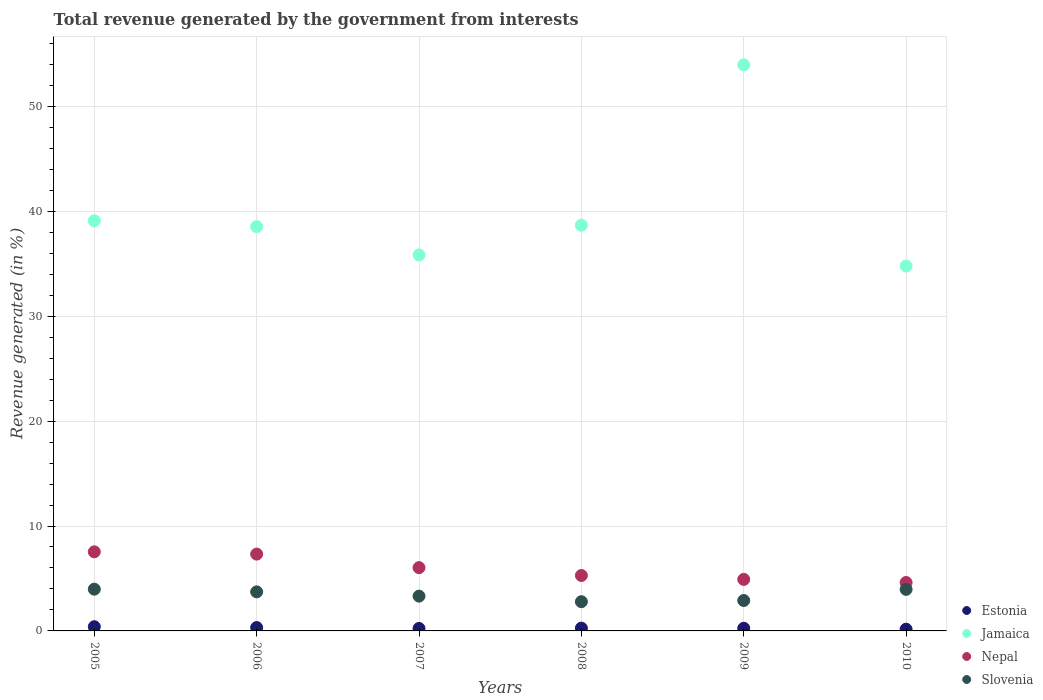What is the total revenue generated in Slovenia in 2008?
Give a very brief answer. 2.79. Across all years, what is the maximum total revenue generated in Jamaica?
Make the answer very short. 53.97. Across all years, what is the minimum total revenue generated in Slovenia?
Give a very brief answer. 2.79. What is the total total revenue generated in Slovenia in the graph?
Offer a terse response. 20.66. What is the difference between the total revenue generated in Jamaica in 2006 and that in 2008?
Make the answer very short. -0.14. What is the difference between the total revenue generated in Jamaica in 2009 and the total revenue generated in Slovenia in 2010?
Your answer should be compact. 50. What is the average total revenue generated in Estonia per year?
Make the answer very short. 0.27. In the year 2007, what is the difference between the total revenue generated in Nepal and total revenue generated in Slovenia?
Your answer should be very brief. 2.72. What is the ratio of the total revenue generated in Jamaica in 2005 to that in 2010?
Ensure brevity in your answer.  1.12. Is the total revenue generated in Jamaica in 2005 less than that in 2009?
Give a very brief answer. Yes. What is the difference between the highest and the second highest total revenue generated in Slovenia?
Ensure brevity in your answer.  0.02. What is the difference between the highest and the lowest total revenue generated in Jamaica?
Keep it short and to the point. 19.18. In how many years, is the total revenue generated in Slovenia greater than the average total revenue generated in Slovenia taken over all years?
Provide a short and direct response. 3. Is the sum of the total revenue generated in Jamaica in 2008 and 2009 greater than the maximum total revenue generated in Nepal across all years?
Make the answer very short. Yes. Does the total revenue generated in Jamaica monotonically increase over the years?
Provide a short and direct response. No. Is the total revenue generated in Slovenia strictly greater than the total revenue generated in Nepal over the years?
Provide a succinct answer. No. How many years are there in the graph?
Provide a short and direct response. 6. Are the values on the major ticks of Y-axis written in scientific E-notation?
Keep it short and to the point. No. Does the graph contain grids?
Offer a very short reply. Yes. How many legend labels are there?
Your answer should be compact. 4. What is the title of the graph?
Ensure brevity in your answer.  Total revenue generated by the government from interests. Does "Slovenia" appear as one of the legend labels in the graph?
Ensure brevity in your answer.  Yes. What is the label or title of the X-axis?
Your answer should be very brief. Years. What is the label or title of the Y-axis?
Offer a very short reply. Revenue generated (in %). What is the Revenue generated (in %) of Estonia in 2005?
Offer a terse response. 0.4. What is the Revenue generated (in %) of Jamaica in 2005?
Your answer should be compact. 39.1. What is the Revenue generated (in %) in Nepal in 2005?
Offer a very short reply. 7.54. What is the Revenue generated (in %) of Slovenia in 2005?
Ensure brevity in your answer.  3.98. What is the Revenue generated (in %) in Estonia in 2006?
Offer a very short reply. 0.32. What is the Revenue generated (in %) in Jamaica in 2006?
Keep it short and to the point. 38.54. What is the Revenue generated (in %) of Nepal in 2006?
Give a very brief answer. 7.32. What is the Revenue generated (in %) in Slovenia in 2006?
Make the answer very short. 3.72. What is the Revenue generated (in %) in Estonia in 2007?
Your answer should be compact. 0.24. What is the Revenue generated (in %) of Jamaica in 2007?
Keep it short and to the point. 35.84. What is the Revenue generated (in %) of Nepal in 2007?
Ensure brevity in your answer.  6.03. What is the Revenue generated (in %) in Slovenia in 2007?
Your answer should be very brief. 3.32. What is the Revenue generated (in %) of Estonia in 2008?
Make the answer very short. 0.26. What is the Revenue generated (in %) of Jamaica in 2008?
Provide a short and direct response. 38.68. What is the Revenue generated (in %) in Nepal in 2008?
Keep it short and to the point. 5.28. What is the Revenue generated (in %) in Slovenia in 2008?
Make the answer very short. 2.79. What is the Revenue generated (in %) in Estonia in 2009?
Ensure brevity in your answer.  0.25. What is the Revenue generated (in %) of Jamaica in 2009?
Offer a very short reply. 53.97. What is the Revenue generated (in %) in Nepal in 2009?
Ensure brevity in your answer.  4.91. What is the Revenue generated (in %) in Slovenia in 2009?
Your response must be concise. 2.9. What is the Revenue generated (in %) in Estonia in 2010?
Provide a succinct answer. 0.17. What is the Revenue generated (in %) of Jamaica in 2010?
Provide a succinct answer. 34.79. What is the Revenue generated (in %) in Nepal in 2010?
Your answer should be very brief. 4.62. What is the Revenue generated (in %) in Slovenia in 2010?
Make the answer very short. 3.96. Across all years, what is the maximum Revenue generated (in %) in Estonia?
Make the answer very short. 0.4. Across all years, what is the maximum Revenue generated (in %) of Jamaica?
Provide a succinct answer. 53.97. Across all years, what is the maximum Revenue generated (in %) in Nepal?
Give a very brief answer. 7.54. Across all years, what is the maximum Revenue generated (in %) in Slovenia?
Ensure brevity in your answer.  3.98. Across all years, what is the minimum Revenue generated (in %) in Estonia?
Provide a succinct answer. 0.17. Across all years, what is the minimum Revenue generated (in %) in Jamaica?
Offer a terse response. 34.79. Across all years, what is the minimum Revenue generated (in %) of Nepal?
Provide a succinct answer. 4.62. Across all years, what is the minimum Revenue generated (in %) in Slovenia?
Offer a very short reply. 2.79. What is the total Revenue generated (in %) in Estonia in the graph?
Your answer should be very brief. 1.64. What is the total Revenue generated (in %) in Jamaica in the graph?
Offer a terse response. 240.91. What is the total Revenue generated (in %) of Nepal in the graph?
Your answer should be compact. 35.71. What is the total Revenue generated (in %) in Slovenia in the graph?
Give a very brief answer. 20.66. What is the difference between the Revenue generated (in %) of Estonia in 2005 and that in 2006?
Provide a succinct answer. 0.08. What is the difference between the Revenue generated (in %) in Jamaica in 2005 and that in 2006?
Offer a very short reply. 0.56. What is the difference between the Revenue generated (in %) in Nepal in 2005 and that in 2006?
Provide a short and direct response. 0.22. What is the difference between the Revenue generated (in %) in Slovenia in 2005 and that in 2006?
Your response must be concise. 0.26. What is the difference between the Revenue generated (in %) in Estonia in 2005 and that in 2007?
Offer a terse response. 0.16. What is the difference between the Revenue generated (in %) of Jamaica in 2005 and that in 2007?
Your response must be concise. 3.25. What is the difference between the Revenue generated (in %) of Nepal in 2005 and that in 2007?
Your response must be concise. 1.51. What is the difference between the Revenue generated (in %) of Slovenia in 2005 and that in 2007?
Your answer should be compact. 0.66. What is the difference between the Revenue generated (in %) of Estonia in 2005 and that in 2008?
Make the answer very short. 0.14. What is the difference between the Revenue generated (in %) in Jamaica in 2005 and that in 2008?
Your answer should be very brief. 0.42. What is the difference between the Revenue generated (in %) in Nepal in 2005 and that in 2008?
Make the answer very short. 2.26. What is the difference between the Revenue generated (in %) in Slovenia in 2005 and that in 2008?
Provide a short and direct response. 1.19. What is the difference between the Revenue generated (in %) of Estonia in 2005 and that in 2009?
Ensure brevity in your answer.  0.15. What is the difference between the Revenue generated (in %) in Jamaica in 2005 and that in 2009?
Keep it short and to the point. -14.87. What is the difference between the Revenue generated (in %) of Nepal in 2005 and that in 2009?
Offer a very short reply. 2.63. What is the difference between the Revenue generated (in %) of Slovenia in 2005 and that in 2009?
Keep it short and to the point. 1.08. What is the difference between the Revenue generated (in %) of Estonia in 2005 and that in 2010?
Provide a short and direct response. 0.24. What is the difference between the Revenue generated (in %) of Jamaica in 2005 and that in 2010?
Keep it short and to the point. 4.31. What is the difference between the Revenue generated (in %) in Nepal in 2005 and that in 2010?
Provide a short and direct response. 2.93. What is the difference between the Revenue generated (in %) in Slovenia in 2005 and that in 2010?
Your answer should be compact. 0.02. What is the difference between the Revenue generated (in %) in Estonia in 2006 and that in 2007?
Keep it short and to the point. 0.08. What is the difference between the Revenue generated (in %) in Jamaica in 2006 and that in 2007?
Provide a succinct answer. 2.7. What is the difference between the Revenue generated (in %) in Nepal in 2006 and that in 2007?
Offer a terse response. 1.29. What is the difference between the Revenue generated (in %) in Slovenia in 2006 and that in 2007?
Ensure brevity in your answer.  0.41. What is the difference between the Revenue generated (in %) in Estonia in 2006 and that in 2008?
Ensure brevity in your answer.  0.06. What is the difference between the Revenue generated (in %) of Jamaica in 2006 and that in 2008?
Make the answer very short. -0.14. What is the difference between the Revenue generated (in %) in Nepal in 2006 and that in 2008?
Offer a terse response. 2.04. What is the difference between the Revenue generated (in %) in Slovenia in 2006 and that in 2008?
Your answer should be very brief. 0.94. What is the difference between the Revenue generated (in %) of Estonia in 2006 and that in 2009?
Provide a short and direct response. 0.07. What is the difference between the Revenue generated (in %) in Jamaica in 2006 and that in 2009?
Provide a succinct answer. -15.42. What is the difference between the Revenue generated (in %) of Nepal in 2006 and that in 2009?
Make the answer very short. 2.41. What is the difference between the Revenue generated (in %) of Slovenia in 2006 and that in 2009?
Offer a terse response. 0.82. What is the difference between the Revenue generated (in %) of Estonia in 2006 and that in 2010?
Your answer should be compact. 0.15. What is the difference between the Revenue generated (in %) in Jamaica in 2006 and that in 2010?
Your answer should be very brief. 3.76. What is the difference between the Revenue generated (in %) in Nepal in 2006 and that in 2010?
Give a very brief answer. 2.71. What is the difference between the Revenue generated (in %) in Slovenia in 2006 and that in 2010?
Provide a succinct answer. -0.24. What is the difference between the Revenue generated (in %) of Estonia in 2007 and that in 2008?
Keep it short and to the point. -0.03. What is the difference between the Revenue generated (in %) of Jamaica in 2007 and that in 2008?
Make the answer very short. -2.83. What is the difference between the Revenue generated (in %) in Nepal in 2007 and that in 2008?
Your answer should be very brief. 0.75. What is the difference between the Revenue generated (in %) in Slovenia in 2007 and that in 2008?
Offer a terse response. 0.53. What is the difference between the Revenue generated (in %) of Estonia in 2007 and that in 2009?
Offer a terse response. -0.02. What is the difference between the Revenue generated (in %) of Jamaica in 2007 and that in 2009?
Offer a very short reply. -18.12. What is the difference between the Revenue generated (in %) of Nepal in 2007 and that in 2009?
Keep it short and to the point. 1.12. What is the difference between the Revenue generated (in %) in Slovenia in 2007 and that in 2009?
Offer a terse response. 0.42. What is the difference between the Revenue generated (in %) of Estonia in 2007 and that in 2010?
Ensure brevity in your answer.  0.07. What is the difference between the Revenue generated (in %) of Jamaica in 2007 and that in 2010?
Make the answer very short. 1.06. What is the difference between the Revenue generated (in %) of Nepal in 2007 and that in 2010?
Keep it short and to the point. 1.42. What is the difference between the Revenue generated (in %) in Slovenia in 2007 and that in 2010?
Your answer should be very brief. -0.64. What is the difference between the Revenue generated (in %) of Estonia in 2008 and that in 2009?
Your response must be concise. 0.01. What is the difference between the Revenue generated (in %) of Jamaica in 2008 and that in 2009?
Keep it short and to the point. -15.29. What is the difference between the Revenue generated (in %) in Nepal in 2008 and that in 2009?
Your answer should be very brief. 0.37. What is the difference between the Revenue generated (in %) in Slovenia in 2008 and that in 2009?
Provide a succinct answer. -0.11. What is the difference between the Revenue generated (in %) in Estonia in 2008 and that in 2010?
Your answer should be very brief. 0.1. What is the difference between the Revenue generated (in %) in Jamaica in 2008 and that in 2010?
Make the answer very short. 3.89. What is the difference between the Revenue generated (in %) of Nepal in 2008 and that in 2010?
Your answer should be very brief. 0.67. What is the difference between the Revenue generated (in %) in Slovenia in 2008 and that in 2010?
Offer a very short reply. -1.17. What is the difference between the Revenue generated (in %) of Estonia in 2009 and that in 2010?
Offer a very short reply. 0.09. What is the difference between the Revenue generated (in %) of Jamaica in 2009 and that in 2010?
Your answer should be compact. 19.18. What is the difference between the Revenue generated (in %) in Nepal in 2009 and that in 2010?
Make the answer very short. 0.3. What is the difference between the Revenue generated (in %) of Slovenia in 2009 and that in 2010?
Ensure brevity in your answer.  -1.06. What is the difference between the Revenue generated (in %) in Estonia in 2005 and the Revenue generated (in %) in Jamaica in 2006?
Offer a terse response. -38.14. What is the difference between the Revenue generated (in %) of Estonia in 2005 and the Revenue generated (in %) of Nepal in 2006?
Your answer should be compact. -6.92. What is the difference between the Revenue generated (in %) in Estonia in 2005 and the Revenue generated (in %) in Slovenia in 2006?
Offer a very short reply. -3.32. What is the difference between the Revenue generated (in %) of Jamaica in 2005 and the Revenue generated (in %) of Nepal in 2006?
Ensure brevity in your answer.  31.77. What is the difference between the Revenue generated (in %) of Jamaica in 2005 and the Revenue generated (in %) of Slovenia in 2006?
Give a very brief answer. 35.37. What is the difference between the Revenue generated (in %) of Nepal in 2005 and the Revenue generated (in %) of Slovenia in 2006?
Your answer should be compact. 3.82. What is the difference between the Revenue generated (in %) in Estonia in 2005 and the Revenue generated (in %) in Jamaica in 2007?
Ensure brevity in your answer.  -35.44. What is the difference between the Revenue generated (in %) in Estonia in 2005 and the Revenue generated (in %) in Nepal in 2007?
Keep it short and to the point. -5.63. What is the difference between the Revenue generated (in %) in Estonia in 2005 and the Revenue generated (in %) in Slovenia in 2007?
Give a very brief answer. -2.92. What is the difference between the Revenue generated (in %) of Jamaica in 2005 and the Revenue generated (in %) of Nepal in 2007?
Your response must be concise. 33.06. What is the difference between the Revenue generated (in %) in Jamaica in 2005 and the Revenue generated (in %) in Slovenia in 2007?
Offer a very short reply. 35.78. What is the difference between the Revenue generated (in %) of Nepal in 2005 and the Revenue generated (in %) of Slovenia in 2007?
Give a very brief answer. 4.22. What is the difference between the Revenue generated (in %) in Estonia in 2005 and the Revenue generated (in %) in Jamaica in 2008?
Make the answer very short. -38.28. What is the difference between the Revenue generated (in %) in Estonia in 2005 and the Revenue generated (in %) in Nepal in 2008?
Provide a short and direct response. -4.88. What is the difference between the Revenue generated (in %) of Estonia in 2005 and the Revenue generated (in %) of Slovenia in 2008?
Your answer should be compact. -2.38. What is the difference between the Revenue generated (in %) of Jamaica in 2005 and the Revenue generated (in %) of Nepal in 2008?
Make the answer very short. 33.81. What is the difference between the Revenue generated (in %) in Jamaica in 2005 and the Revenue generated (in %) in Slovenia in 2008?
Your response must be concise. 36.31. What is the difference between the Revenue generated (in %) of Nepal in 2005 and the Revenue generated (in %) of Slovenia in 2008?
Offer a terse response. 4.75. What is the difference between the Revenue generated (in %) of Estonia in 2005 and the Revenue generated (in %) of Jamaica in 2009?
Your response must be concise. -53.56. What is the difference between the Revenue generated (in %) in Estonia in 2005 and the Revenue generated (in %) in Nepal in 2009?
Offer a very short reply. -4.51. What is the difference between the Revenue generated (in %) of Estonia in 2005 and the Revenue generated (in %) of Slovenia in 2009?
Ensure brevity in your answer.  -2.5. What is the difference between the Revenue generated (in %) of Jamaica in 2005 and the Revenue generated (in %) of Nepal in 2009?
Make the answer very short. 34.18. What is the difference between the Revenue generated (in %) of Jamaica in 2005 and the Revenue generated (in %) of Slovenia in 2009?
Ensure brevity in your answer.  36.2. What is the difference between the Revenue generated (in %) in Nepal in 2005 and the Revenue generated (in %) in Slovenia in 2009?
Ensure brevity in your answer.  4.64. What is the difference between the Revenue generated (in %) in Estonia in 2005 and the Revenue generated (in %) in Jamaica in 2010?
Provide a succinct answer. -34.38. What is the difference between the Revenue generated (in %) in Estonia in 2005 and the Revenue generated (in %) in Nepal in 2010?
Make the answer very short. -4.21. What is the difference between the Revenue generated (in %) of Estonia in 2005 and the Revenue generated (in %) of Slovenia in 2010?
Give a very brief answer. -3.56. What is the difference between the Revenue generated (in %) of Jamaica in 2005 and the Revenue generated (in %) of Nepal in 2010?
Ensure brevity in your answer.  34.48. What is the difference between the Revenue generated (in %) in Jamaica in 2005 and the Revenue generated (in %) in Slovenia in 2010?
Ensure brevity in your answer.  35.14. What is the difference between the Revenue generated (in %) of Nepal in 2005 and the Revenue generated (in %) of Slovenia in 2010?
Your answer should be very brief. 3.58. What is the difference between the Revenue generated (in %) of Estonia in 2006 and the Revenue generated (in %) of Jamaica in 2007?
Provide a succinct answer. -35.52. What is the difference between the Revenue generated (in %) in Estonia in 2006 and the Revenue generated (in %) in Nepal in 2007?
Provide a short and direct response. -5.71. What is the difference between the Revenue generated (in %) of Estonia in 2006 and the Revenue generated (in %) of Slovenia in 2007?
Ensure brevity in your answer.  -3. What is the difference between the Revenue generated (in %) in Jamaica in 2006 and the Revenue generated (in %) in Nepal in 2007?
Provide a succinct answer. 32.51. What is the difference between the Revenue generated (in %) of Jamaica in 2006 and the Revenue generated (in %) of Slovenia in 2007?
Provide a succinct answer. 35.22. What is the difference between the Revenue generated (in %) of Nepal in 2006 and the Revenue generated (in %) of Slovenia in 2007?
Provide a succinct answer. 4.01. What is the difference between the Revenue generated (in %) of Estonia in 2006 and the Revenue generated (in %) of Jamaica in 2008?
Offer a very short reply. -38.36. What is the difference between the Revenue generated (in %) of Estonia in 2006 and the Revenue generated (in %) of Nepal in 2008?
Offer a terse response. -4.96. What is the difference between the Revenue generated (in %) of Estonia in 2006 and the Revenue generated (in %) of Slovenia in 2008?
Keep it short and to the point. -2.47. What is the difference between the Revenue generated (in %) in Jamaica in 2006 and the Revenue generated (in %) in Nepal in 2008?
Offer a very short reply. 33.26. What is the difference between the Revenue generated (in %) of Jamaica in 2006 and the Revenue generated (in %) of Slovenia in 2008?
Provide a short and direct response. 35.75. What is the difference between the Revenue generated (in %) of Nepal in 2006 and the Revenue generated (in %) of Slovenia in 2008?
Provide a succinct answer. 4.54. What is the difference between the Revenue generated (in %) of Estonia in 2006 and the Revenue generated (in %) of Jamaica in 2009?
Your answer should be compact. -53.64. What is the difference between the Revenue generated (in %) in Estonia in 2006 and the Revenue generated (in %) in Nepal in 2009?
Offer a terse response. -4.59. What is the difference between the Revenue generated (in %) of Estonia in 2006 and the Revenue generated (in %) of Slovenia in 2009?
Your answer should be compact. -2.58. What is the difference between the Revenue generated (in %) in Jamaica in 2006 and the Revenue generated (in %) in Nepal in 2009?
Keep it short and to the point. 33.63. What is the difference between the Revenue generated (in %) in Jamaica in 2006 and the Revenue generated (in %) in Slovenia in 2009?
Provide a short and direct response. 35.64. What is the difference between the Revenue generated (in %) of Nepal in 2006 and the Revenue generated (in %) of Slovenia in 2009?
Offer a terse response. 4.43. What is the difference between the Revenue generated (in %) of Estonia in 2006 and the Revenue generated (in %) of Jamaica in 2010?
Offer a terse response. -34.47. What is the difference between the Revenue generated (in %) in Estonia in 2006 and the Revenue generated (in %) in Nepal in 2010?
Ensure brevity in your answer.  -4.3. What is the difference between the Revenue generated (in %) of Estonia in 2006 and the Revenue generated (in %) of Slovenia in 2010?
Offer a terse response. -3.64. What is the difference between the Revenue generated (in %) in Jamaica in 2006 and the Revenue generated (in %) in Nepal in 2010?
Keep it short and to the point. 33.92. What is the difference between the Revenue generated (in %) in Jamaica in 2006 and the Revenue generated (in %) in Slovenia in 2010?
Ensure brevity in your answer.  34.58. What is the difference between the Revenue generated (in %) of Nepal in 2006 and the Revenue generated (in %) of Slovenia in 2010?
Keep it short and to the point. 3.36. What is the difference between the Revenue generated (in %) in Estonia in 2007 and the Revenue generated (in %) in Jamaica in 2008?
Make the answer very short. -38.44. What is the difference between the Revenue generated (in %) of Estonia in 2007 and the Revenue generated (in %) of Nepal in 2008?
Give a very brief answer. -5.05. What is the difference between the Revenue generated (in %) in Estonia in 2007 and the Revenue generated (in %) in Slovenia in 2008?
Offer a very short reply. -2.55. What is the difference between the Revenue generated (in %) of Jamaica in 2007 and the Revenue generated (in %) of Nepal in 2008?
Your answer should be very brief. 30.56. What is the difference between the Revenue generated (in %) of Jamaica in 2007 and the Revenue generated (in %) of Slovenia in 2008?
Offer a very short reply. 33.06. What is the difference between the Revenue generated (in %) in Nepal in 2007 and the Revenue generated (in %) in Slovenia in 2008?
Provide a succinct answer. 3.25. What is the difference between the Revenue generated (in %) in Estonia in 2007 and the Revenue generated (in %) in Jamaica in 2009?
Give a very brief answer. -53.73. What is the difference between the Revenue generated (in %) of Estonia in 2007 and the Revenue generated (in %) of Nepal in 2009?
Provide a short and direct response. -4.67. What is the difference between the Revenue generated (in %) of Estonia in 2007 and the Revenue generated (in %) of Slovenia in 2009?
Keep it short and to the point. -2.66. What is the difference between the Revenue generated (in %) of Jamaica in 2007 and the Revenue generated (in %) of Nepal in 2009?
Offer a terse response. 30.93. What is the difference between the Revenue generated (in %) in Jamaica in 2007 and the Revenue generated (in %) in Slovenia in 2009?
Keep it short and to the point. 32.94. What is the difference between the Revenue generated (in %) of Nepal in 2007 and the Revenue generated (in %) of Slovenia in 2009?
Your answer should be very brief. 3.13. What is the difference between the Revenue generated (in %) of Estonia in 2007 and the Revenue generated (in %) of Jamaica in 2010?
Your response must be concise. -34.55. What is the difference between the Revenue generated (in %) in Estonia in 2007 and the Revenue generated (in %) in Nepal in 2010?
Offer a terse response. -4.38. What is the difference between the Revenue generated (in %) in Estonia in 2007 and the Revenue generated (in %) in Slovenia in 2010?
Your answer should be compact. -3.72. What is the difference between the Revenue generated (in %) of Jamaica in 2007 and the Revenue generated (in %) of Nepal in 2010?
Provide a succinct answer. 31.23. What is the difference between the Revenue generated (in %) in Jamaica in 2007 and the Revenue generated (in %) in Slovenia in 2010?
Provide a succinct answer. 31.88. What is the difference between the Revenue generated (in %) of Nepal in 2007 and the Revenue generated (in %) of Slovenia in 2010?
Provide a succinct answer. 2.07. What is the difference between the Revenue generated (in %) in Estonia in 2008 and the Revenue generated (in %) in Jamaica in 2009?
Offer a very short reply. -53.7. What is the difference between the Revenue generated (in %) of Estonia in 2008 and the Revenue generated (in %) of Nepal in 2009?
Offer a terse response. -4.65. What is the difference between the Revenue generated (in %) in Estonia in 2008 and the Revenue generated (in %) in Slovenia in 2009?
Ensure brevity in your answer.  -2.63. What is the difference between the Revenue generated (in %) in Jamaica in 2008 and the Revenue generated (in %) in Nepal in 2009?
Make the answer very short. 33.76. What is the difference between the Revenue generated (in %) in Jamaica in 2008 and the Revenue generated (in %) in Slovenia in 2009?
Offer a terse response. 35.78. What is the difference between the Revenue generated (in %) of Nepal in 2008 and the Revenue generated (in %) of Slovenia in 2009?
Your response must be concise. 2.38. What is the difference between the Revenue generated (in %) of Estonia in 2008 and the Revenue generated (in %) of Jamaica in 2010?
Offer a very short reply. -34.52. What is the difference between the Revenue generated (in %) in Estonia in 2008 and the Revenue generated (in %) in Nepal in 2010?
Keep it short and to the point. -4.35. What is the difference between the Revenue generated (in %) of Estonia in 2008 and the Revenue generated (in %) of Slovenia in 2010?
Your answer should be very brief. -3.7. What is the difference between the Revenue generated (in %) in Jamaica in 2008 and the Revenue generated (in %) in Nepal in 2010?
Provide a succinct answer. 34.06. What is the difference between the Revenue generated (in %) of Jamaica in 2008 and the Revenue generated (in %) of Slovenia in 2010?
Your answer should be very brief. 34.72. What is the difference between the Revenue generated (in %) of Nepal in 2008 and the Revenue generated (in %) of Slovenia in 2010?
Make the answer very short. 1.32. What is the difference between the Revenue generated (in %) of Estonia in 2009 and the Revenue generated (in %) of Jamaica in 2010?
Give a very brief answer. -34.53. What is the difference between the Revenue generated (in %) in Estonia in 2009 and the Revenue generated (in %) in Nepal in 2010?
Your answer should be very brief. -4.36. What is the difference between the Revenue generated (in %) of Estonia in 2009 and the Revenue generated (in %) of Slovenia in 2010?
Offer a terse response. -3.71. What is the difference between the Revenue generated (in %) in Jamaica in 2009 and the Revenue generated (in %) in Nepal in 2010?
Offer a very short reply. 49.35. What is the difference between the Revenue generated (in %) of Jamaica in 2009 and the Revenue generated (in %) of Slovenia in 2010?
Offer a very short reply. 50. What is the difference between the Revenue generated (in %) of Nepal in 2009 and the Revenue generated (in %) of Slovenia in 2010?
Make the answer very short. 0.95. What is the average Revenue generated (in %) of Estonia per year?
Give a very brief answer. 0.27. What is the average Revenue generated (in %) of Jamaica per year?
Ensure brevity in your answer.  40.15. What is the average Revenue generated (in %) in Nepal per year?
Give a very brief answer. 5.95. What is the average Revenue generated (in %) of Slovenia per year?
Your response must be concise. 3.44. In the year 2005, what is the difference between the Revenue generated (in %) in Estonia and Revenue generated (in %) in Jamaica?
Your answer should be very brief. -38.69. In the year 2005, what is the difference between the Revenue generated (in %) of Estonia and Revenue generated (in %) of Nepal?
Ensure brevity in your answer.  -7.14. In the year 2005, what is the difference between the Revenue generated (in %) of Estonia and Revenue generated (in %) of Slovenia?
Keep it short and to the point. -3.58. In the year 2005, what is the difference between the Revenue generated (in %) of Jamaica and Revenue generated (in %) of Nepal?
Provide a short and direct response. 31.56. In the year 2005, what is the difference between the Revenue generated (in %) of Jamaica and Revenue generated (in %) of Slovenia?
Give a very brief answer. 35.12. In the year 2005, what is the difference between the Revenue generated (in %) of Nepal and Revenue generated (in %) of Slovenia?
Your response must be concise. 3.56. In the year 2006, what is the difference between the Revenue generated (in %) of Estonia and Revenue generated (in %) of Jamaica?
Keep it short and to the point. -38.22. In the year 2006, what is the difference between the Revenue generated (in %) of Estonia and Revenue generated (in %) of Nepal?
Ensure brevity in your answer.  -7. In the year 2006, what is the difference between the Revenue generated (in %) in Estonia and Revenue generated (in %) in Slovenia?
Make the answer very short. -3.4. In the year 2006, what is the difference between the Revenue generated (in %) in Jamaica and Revenue generated (in %) in Nepal?
Keep it short and to the point. 31.22. In the year 2006, what is the difference between the Revenue generated (in %) of Jamaica and Revenue generated (in %) of Slovenia?
Your answer should be very brief. 34.82. In the year 2006, what is the difference between the Revenue generated (in %) of Nepal and Revenue generated (in %) of Slovenia?
Give a very brief answer. 3.6. In the year 2007, what is the difference between the Revenue generated (in %) of Estonia and Revenue generated (in %) of Jamaica?
Your response must be concise. -35.6. In the year 2007, what is the difference between the Revenue generated (in %) of Estonia and Revenue generated (in %) of Nepal?
Keep it short and to the point. -5.79. In the year 2007, what is the difference between the Revenue generated (in %) of Estonia and Revenue generated (in %) of Slovenia?
Provide a short and direct response. -3.08. In the year 2007, what is the difference between the Revenue generated (in %) of Jamaica and Revenue generated (in %) of Nepal?
Your response must be concise. 29.81. In the year 2007, what is the difference between the Revenue generated (in %) in Jamaica and Revenue generated (in %) in Slovenia?
Your answer should be very brief. 32.53. In the year 2007, what is the difference between the Revenue generated (in %) in Nepal and Revenue generated (in %) in Slovenia?
Your response must be concise. 2.72. In the year 2008, what is the difference between the Revenue generated (in %) in Estonia and Revenue generated (in %) in Jamaica?
Keep it short and to the point. -38.41. In the year 2008, what is the difference between the Revenue generated (in %) of Estonia and Revenue generated (in %) of Nepal?
Provide a succinct answer. -5.02. In the year 2008, what is the difference between the Revenue generated (in %) of Estonia and Revenue generated (in %) of Slovenia?
Give a very brief answer. -2.52. In the year 2008, what is the difference between the Revenue generated (in %) of Jamaica and Revenue generated (in %) of Nepal?
Provide a short and direct response. 33.39. In the year 2008, what is the difference between the Revenue generated (in %) in Jamaica and Revenue generated (in %) in Slovenia?
Give a very brief answer. 35.89. In the year 2008, what is the difference between the Revenue generated (in %) of Nepal and Revenue generated (in %) of Slovenia?
Ensure brevity in your answer.  2.5. In the year 2009, what is the difference between the Revenue generated (in %) of Estonia and Revenue generated (in %) of Jamaica?
Offer a terse response. -53.71. In the year 2009, what is the difference between the Revenue generated (in %) in Estonia and Revenue generated (in %) in Nepal?
Your answer should be compact. -4.66. In the year 2009, what is the difference between the Revenue generated (in %) in Estonia and Revenue generated (in %) in Slovenia?
Your response must be concise. -2.65. In the year 2009, what is the difference between the Revenue generated (in %) in Jamaica and Revenue generated (in %) in Nepal?
Provide a succinct answer. 49.05. In the year 2009, what is the difference between the Revenue generated (in %) of Jamaica and Revenue generated (in %) of Slovenia?
Give a very brief answer. 51.07. In the year 2009, what is the difference between the Revenue generated (in %) of Nepal and Revenue generated (in %) of Slovenia?
Ensure brevity in your answer.  2.01. In the year 2010, what is the difference between the Revenue generated (in %) in Estonia and Revenue generated (in %) in Jamaica?
Provide a succinct answer. -34.62. In the year 2010, what is the difference between the Revenue generated (in %) in Estonia and Revenue generated (in %) in Nepal?
Offer a very short reply. -4.45. In the year 2010, what is the difference between the Revenue generated (in %) in Estonia and Revenue generated (in %) in Slovenia?
Keep it short and to the point. -3.8. In the year 2010, what is the difference between the Revenue generated (in %) in Jamaica and Revenue generated (in %) in Nepal?
Offer a terse response. 30.17. In the year 2010, what is the difference between the Revenue generated (in %) of Jamaica and Revenue generated (in %) of Slovenia?
Make the answer very short. 30.82. In the year 2010, what is the difference between the Revenue generated (in %) in Nepal and Revenue generated (in %) in Slovenia?
Provide a succinct answer. 0.65. What is the ratio of the Revenue generated (in %) in Estonia in 2005 to that in 2006?
Provide a succinct answer. 1.25. What is the ratio of the Revenue generated (in %) in Jamaica in 2005 to that in 2006?
Keep it short and to the point. 1.01. What is the ratio of the Revenue generated (in %) of Nepal in 2005 to that in 2006?
Give a very brief answer. 1.03. What is the ratio of the Revenue generated (in %) of Slovenia in 2005 to that in 2006?
Your response must be concise. 1.07. What is the ratio of the Revenue generated (in %) of Estonia in 2005 to that in 2007?
Ensure brevity in your answer.  1.69. What is the ratio of the Revenue generated (in %) of Jamaica in 2005 to that in 2007?
Your response must be concise. 1.09. What is the ratio of the Revenue generated (in %) in Nepal in 2005 to that in 2007?
Provide a succinct answer. 1.25. What is the ratio of the Revenue generated (in %) of Estonia in 2005 to that in 2008?
Make the answer very short. 1.52. What is the ratio of the Revenue generated (in %) of Jamaica in 2005 to that in 2008?
Provide a succinct answer. 1.01. What is the ratio of the Revenue generated (in %) of Nepal in 2005 to that in 2008?
Give a very brief answer. 1.43. What is the ratio of the Revenue generated (in %) in Slovenia in 2005 to that in 2008?
Keep it short and to the point. 1.43. What is the ratio of the Revenue generated (in %) in Estonia in 2005 to that in 2009?
Offer a very short reply. 1.59. What is the ratio of the Revenue generated (in %) of Jamaica in 2005 to that in 2009?
Provide a short and direct response. 0.72. What is the ratio of the Revenue generated (in %) of Nepal in 2005 to that in 2009?
Offer a very short reply. 1.54. What is the ratio of the Revenue generated (in %) in Slovenia in 2005 to that in 2009?
Provide a short and direct response. 1.37. What is the ratio of the Revenue generated (in %) in Estonia in 2005 to that in 2010?
Provide a short and direct response. 2.43. What is the ratio of the Revenue generated (in %) in Jamaica in 2005 to that in 2010?
Offer a very short reply. 1.12. What is the ratio of the Revenue generated (in %) in Nepal in 2005 to that in 2010?
Provide a succinct answer. 1.63. What is the ratio of the Revenue generated (in %) of Estonia in 2006 to that in 2007?
Provide a succinct answer. 1.35. What is the ratio of the Revenue generated (in %) of Jamaica in 2006 to that in 2007?
Ensure brevity in your answer.  1.08. What is the ratio of the Revenue generated (in %) of Nepal in 2006 to that in 2007?
Provide a short and direct response. 1.21. What is the ratio of the Revenue generated (in %) in Slovenia in 2006 to that in 2007?
Your response must be concise. 1.12. What is the ratio of the Revenue generated (in %) of Estonia in 2006 to that in 2008?
Keep it short and to the point. 1.21. What is the ratio of the Revenue generated (in %) in Nepal in 2006 to that in 2008?
Your answer should be very brief. 1.39. What is the ratio of the Revenue generated (in %) of Slovenia in 2006 to that in 2008?
Provide a succinct answer. 1.34. What is the ratio of the Revenue generated (in %) of Estonia in 2006 to that in 2009?
Your answer should be compact. 1.27. What is the ratio of the Revenue generated (in %) of Jamaica in 2006 to that in 2009?
Provide a succinct answer. 0.71. What is the ratio of the Revenue generated (in %) of Nepal in 2006 to that in 2009?
Offer a terse response. 1.49. What is the ratio of the Revenue generated (in %) of Slovenia in 2006 to that in 2009?
Your answer should be compact. 1.28. What is the ratio of the Revenue generated (in %) in Estonia in 2006 to that in 2010?
Keep it short and to the point. 1.94. What is the ratio of the Revenue generated (in %) of Jamaica in 2006 to that in 2010?
Provide a succinct answer. 1.11. What is the ratio of the Revenue generated (in %) of Nepal in 2006 to that in 2010?
Make the answer very short. 1.59. What is the ratio of the Revenue generated (in %) in Slovenia in 2006 to that in 2010?
Provide a short and direct response. 0.94. What is the ratio of the Revenue generated (in %) in Estonia in 2007 to that in 2008?
Your response must be concise. 0.9. What is the ratio of the Revenue generated (in %) in Jamaica in 2007 to that in 2008?
Give a very brief answer. 0.93. What is the ratio of the Revenue generated (in %) of Nepal in 2007 to that in 2008?
Provide a short and direct response. 1.14. What is the ratio of the Revenue generated (in %) of Slovenia in 2007 to that in 2008?
Provide a succinct answer. 1.19. What is the ratio of the Revenue generated (in %) of Estonia in 2007 to that in 2009?
Provide a succinct answer. 0.94. What is the ratio of the Revenue generated (in %) of Jamaica in 2007 to that in 2009?
Ensure brevity in your answer.  0.66. What is the ratio of the Revenue generated (in %) of Nepal in 2007 to that in 2009?
Your answer should be very brief. 1.23. What is the ratio of the Revenue generated (in %) in Slovenia in 2007 to that in 2009?
Keep it short and to the point. 1.14. What is the ratio of the Revenue generated (in %) in Estonia in 2007 to that in 2010?
Make the answer very short. 1.44. What is the ratio of the Revenue generated (in %) in Jamaica in 2007 to that in 2010?
Your answer should be very brief. 1.03. What is the ratio of the Revenue generated (in %) in Nepal in 2007 to that in 2010?
Ensure brevity in your answer.  1.31. What is the ratio of the Revenue generated (in %) in Slovenia in 2007 to that in 2010?
Ensure brevity in your answer.  0.84. What is the ratio of the Revenue generated (in %) in Estonia in 2008 to that in 2009?
Provide a succinct answer. 1.05. What is the ratio of the Revenue generated (in %) in Jamaica in 2008 to that in 2009?
Provide a succinct answer. 0.72. What is the ratio of the Revenue generated (in %) in Nepal in 2008 to that in 2009?
Ensure brevity in your answer.  1.08. What is the ratio of the Revenue generated (in %) of Slovenia in 2008 to that in 2009?
Keep it short and to the point. 0.96. What is the ratio of the Revenue generated (in %) of Estonia in 2008 to that in 2010?
Give a very brief answer. 1.6. What is the ratio of the Revenue generated (in %) in Jamaica in 2008 to that in 2010?
Provide a succinct answer. 1.11. What is the ratio of the Revenue generated (in %) in Nepal in 2008 to that in 2010?
Your response must be concise. 1.14. What is the ratio of the Revenue generated (in %) in Slovenia in 2008 to that in 2010?
Offer a terse response. 0.7. What is the ratio of the Revenue generated (in %) in Estonia in 2009 to that in 2010?
Provide a short and direct response. 1.53. What is the ratio of the Revenue generated (in %) of Jamaica in 2009 to that in 2010?
Provide a short and direct response. 1.55. What is the ratio of the Revenue generated (in %) of Nepal in 2009 to that in 2010?
Offer a terse response. 1.06. What is the ratio of the Revenue generated (in %) in Slovenia in 2009 to that in 2010?
Give a very brief answer. 0.73. What is the difference between the highest and the second highest Revenue generated (in %) in Estonia?
Your answer should be compact. 0.08. What is the difference between the highest and the second highest Revenue generated (in %) of Jamaica?
Keep it short and to the point. 14.87. What is the difference between the highest and the second highest Revenue generated (in %) of Nepal?
Provide a succinct answer. 0.22. What is the difference between the highest and the second highest Revenue generated (in %) of Slovenia?
Provide a succinct answer. 0.02. What is the difference between the highest and the lowest Revenue generated (in %) of Estonia?
Provide a succinct answer. 0.24. What is the difference between the highest and the lowest Revenue generated (in %) in Jamaica?
Ensure brevity in your answer.  19.18. What is the difference between the highest and the lowest Revenue generated (in %) in Nepal?
Your response must be concise. 2.93. What is the difference between the highest and the lowest Revenue generated (in %) of Slovenia?
Your answer should be compact. 1.19. 